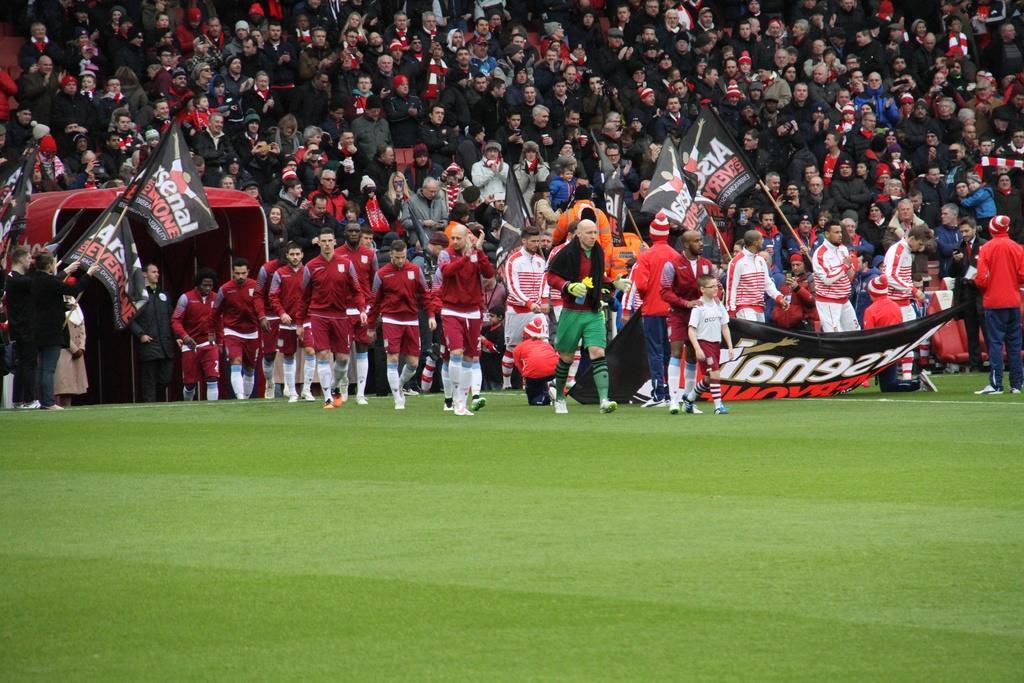Describe this image in one or two sentences. At the bottom we can see grass on the ground and there are two teams players walking on the ground and beside them them there are few persons standing and holding flags in their hands. In the background there are audience. 